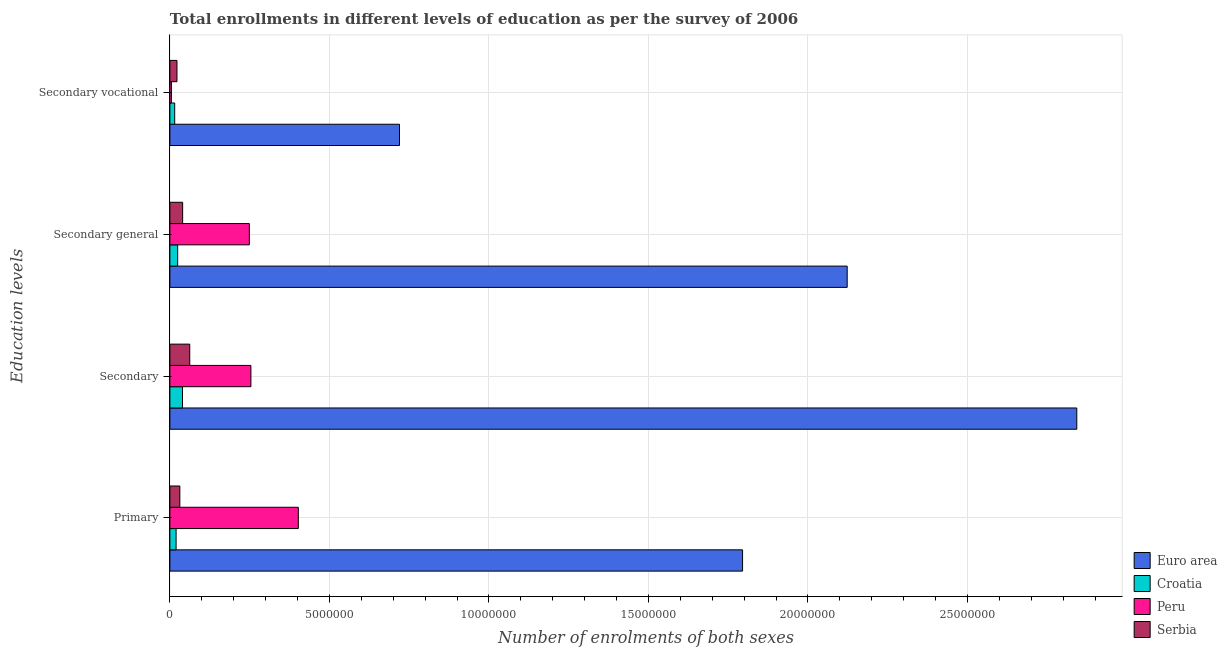How many different coloured bars are there?
Offer a very short reply. 4. How many groups of bars are there?
Provide a succinct answer. 4. Are the number of bars per tick equal to the number of legend labels?
Your response must be concise. Yes. Are the number of bars on each tick of the Y-axis equal?
Provide a short and direct response. Yes. How many bars are there on the 3rd tick from the top?
Your answer should be very brief. 4. What is the label of the 3rd group of bars from the top?
Your answer should be very brief. Secondary. What is the number of enrolments in secondary vocational education in Peru?
Ensure brevity in your answer.  4.86e+04. Across all countries, what is the maximum number of enrolments in primary education?
Offer a very short reply. 1.80e+07. Across all countries, what is the minimum number of enrolments in secondary education?
Ensure brevity in your answer.  3.96e+05. In which country was the number of enrolments in secondary general education minimum?
Offer a very short reply. Croatia. What is the total number of enrolments in secondary general education in the graph?
Provide a short and direct response. 2.44e+07. What is the difference between the number of enrolments in secondary general education in Peru and that in Croatia?
Your response must be concise. 2.25e+06. What is the difference between the number of enrolments in primary education in Serbia and the number of enrolments in secondary general education in Euro area?
Your answer should be compact. -2.09e+07. What is the average number of enrolments in primary education per country?
Ensure brevity in your answer.  5.62e+06. What is the difference between the number of enrolments in primary education and number of enrolments in secondary vocational education in Peru?
Your answer should be very brief. 3.98e+06. In how many countries, is the number of enrolments in primary education greater than 19000000 ?
Your response must be concise. 0. What is the ratio of the number of enrolments in primary education in Serbia to that in Euro area?
Your answer should be compact. 0.02. Is the number of enrolments in secondary vocational education in Serbia less than that in Peru?
Keep it short and to the point. No. What is the difference between the highest and the second highest number of enrolments in secondary general education?
Your answer should be compact. 1.87e+07. What is the difference between the highest and the lowest number of enrolments in primary education?
Keep it short and to the point. 1.78e+07. Is the sum of the number of enrolments in primary education in Peru and Croatia greater than the maximum number of enrolments in secondary education across all countries?
Give a very brief answer. No. What does the 2nd bar from the top in Secondary general represents?
Keep it short and to the point. Peru. Is it the case that in every country, the sum of the number of enrolments in primary education and number of enrolments in secondary education is greater than the number of enrolments in secondary general education?
Offer a very short reply. Yes. How many bars are there?
Give a very brief answer. 16. Are all the bars in the graph horizontal?
Keep it short and to the point. Yes. How many countries are there in the graph?
Make the answer very short. 4. Are the values on the major ticks of X-axis written in scientific E-notation?
Provide a succinct answer. No. Does the graph contain any zero values?
Ensure brevity in your answer.  No. How many legend labels are there?
Ensure brevity in your answer.  4. What is the title of the graph?
Make the answer very short. Total enrollments in different levels of education as per the survey of 2006. Does "Namibia" appear as one of the legend labels in the graph?
Ensure brevity in your answer.  No. What is the label or title of the X-axis?
Keep it short and to the point. Number of enrolments of both sexes. What is the label or title of the Y-axis?
Offer a terse response. Education levels. What is the Number of enrolments of both sexes in Euro area in Primary?
Offer a very short reply. 1.80e+07. What is the Number of enrolments of both sexes in Croatia in Primary?
Keep it short and to the point. 1.95e+05. What is the Number of enrolments of both sexes of Peru in Primary?
Keep it short and to the point. 4.03e+06. What is the Number of enrolments of both sexes of Serbia in Primary?
Keep it short and to the point. 3.13e+05. What is the Number of enrolments of both sexes of Euro area in Secondary?
Make the answer very short. 2.84e+07. What is the Number of enrolments of both sexes of Croatia in Secondary?
Keep it short and to the point. 3.96e+05. What is the Number of enrolments of both sexes in Peru in Secondary?
Provide a succinct answer. 2.54e+06. What is the Number of enrolments of both sexes in Serbia in Secondary?
Make the answer very short. 6.23e+05. What is the Number of enrolments of both sexes of Euro area in Secondary general?
Your answer should be compact. 2.12e+07. What is the Number of enrolments of both sexes in Croatia in Secondary general?
Offer a very short reply. 2.44e+05. What is the Number of enrolments of both sexes of Peru in Secondary general?
Offer a very short reply. 2.49e+06. What is the Number of enrolments of both sexes of Serbia in Secondary general?
Offer a very short reply. 4.00e+05. What is the Number of enrolments of both sexes of Euro area in Secondary vocational?
Your response must be concise. 7.20e+06. What is the Number of enrolments of both sexes in Croatia in Secondary vocational?
Give a very brief answer. 1.51e+05. What is the Number of enrolments of both sexes of Peru in Secondary vocational?
Make the answer very short. 4.86e+04. What is the Number of enrolments of both sexes of Serbia in Secondary vocational?
Offer a terse response. 2.23e+05. Across all Education levels, what is the maximum Number of enrolments of both sexes in Euro area?
Ensure brevity in your answer.  2.84e+07. Across all Education levels, what is the maximum Number of enrolments of both sexes of Croatia?
Provide a succinct answer. 3.96e+05. Across all Education levels, what is the maximum Number of enrolments of both sexes in Peru?
Ensure brevity in your answer.  4.03e+06. Across all Education levels, what is the maximum Number of enrolments of both sexes in Serbia?
Give a very brief answer. 6.23e+05. Across all Education levels, what is the minimum Number of enrolments of both sexes of Euro area?
Make the answer very short. 7.20e+06. Across all Education levels, what is the minimum Number of enrolments of both sexes of Croatia?
Your answer should be compact. 1.51e+05. Across all Education levels, what is the minimum Number of enrolments of both sexes of Peru?
Your response must be concise. 4.86e+04. Across all Education levels, what is the minimum Number of enrolments of both sexes of Serbia?
Provide a succinct answer. 2.23e+05. What is the total Number of enrolments of both sexes in Euro area in the graph?
Your response must be concise. 7.48e+07. What is the total Number of enrolments of both sexes in Croatia in the graph?
Keep it short and to the point. 9.86e+05. What is the total Number of enrolments of both sexes in Peru in the graph?
Keep it short and to the point. 9.11e+06. What is the total Number of enrolments of both sexes of Serbia in the graph?
Keep it short and to the point. 1.56e+06. What is the difference between the Number of enrolments of both sexes of Euro area in Primary and that in Secondary?
Offer a terse response. -1.05e+07. What is the difference between the Number of enrolments of both sexes of Croatia in Primary and that in Secondary?
Make the answer very short. -2.01e+05. What is the difference between the Number of enrolments of both sexes in Peru in Primary and that in Secondary?
Give a very brief answer. 1.49e+06. What is the difference between the Number of enrolments of both sexes of Serbia in Primary and that in Secondary?
Make the answer very short. -3.10e+05. What is the difference between the Number of enrolments of both sexes of Euro area in Primary and that in Secondary general?
Make the answer very short. -3.28e+06. What is the difference between the Number of enrolments of both sexes of Croatia in Primary and that in Secondary general?
Your answer should be compact. -4.96e+04. What is the difference between the Number of enrolments of both sexes in Peru in Primary and that in Secondary general?
Offer a terse response. 1.54e+06. What is the difference between the Number of enrolments of both sexes in Serbia in Primary and that in Secondary general?
Provide a succinct answer. -8.75e+04. What is the difference between the Number of enrolments of both sexes of Euro area in Primary and that in Secondary vocational?
Your answer should be compact. 1.08e+07. What is the difference between the Number of enrolments of both sexes of Croatia in Primary and that in Secondary vocational?
Your response must be concise. 4.33e+04. What is the difference between the Number of enrolments of both sexes of Peru in Primary and that in Secondary vocational?
Your answer should be compact. 3.98e+06. What is the difference between the Number of enrolments of both sexes in Serbia in Primary and that in Secondary vocational?
Offer a very short reply. 8.97e+04. What is the difference between the Number of enrolments of both sexes in Euro area in Secondary and that in Secondary general?
Your response must be concise. 7.20e+06. What is the difference between the Number of enrolments of both sexes of Croatia in Secondary and that in Secondary general?
Your response must be concise. 1.51e+05. What is the difference between the Number of enrolments of both sexes of Peru in Secondary and that in Secondary general?
Make the answer very short. 4.86e+04. What is the difference between the Number of enrolments of both sexes of Serbia in Secondary and that in Secondary general?
Offer a terse response. 2.23e+05. What is the difference between the Number of enrolments of both sexes in Euro area in Secondary and that in Secondary vocational?
Your answer should be compact. 2.12e+07. What is the difference between the Number of enrolments of both sexes in Croatia in Secondary and that in Secondary vocational?
Offer a terse response. 2.44e+05. What is the difference between the Number of enrolments of both sexes in Peru in Secondary and that in Secondary vocational?
Your response must be concise. 2.49e+06. What is the difference between the Number of enrolments of both sexes of Serbia in Secondary and that in Secondary vocational?
Ensure brevity in your answer.  4.00e+05. What is the difference between the Number of enrolments of both sexes in Euro area in Secondary general and that in Secondary vocational?
Give a very brief answer. 1.40e+07. What is the difference between the Number of enrolments of both sexes of Croatia in Secondary general and that in Secondary vocational?
Offer a terse response. 9.29e+04. What is the difference between the Number of enrolments of both sexes in Peru in Secondary general and that in Secondary vocational?
Give a very brief answer. 2.44e+06. What is the difference between the Number of enrolments of both sexes in Serbia in Secondary general and that in Secondary vocational?
Ensure brevity in your answer.  1.77e+05. What is the difference between the Number of enrolments of both sexes of Euro area in Primary and the Number of enrolments of both sexes of Croatia in Secondary?
Ensure brevity in your answer.  1.76e+07. What is the difference between the Number of enrolments of both sexes of Euro area in Primary and the Number of enrolments of both sexes of Peru in Secondary?
Your answer should be very brief. 1.54e+07. What is the difference between the Number of enrolments of both sexes in Euro area in Primary and the Number of enrolments of both sexes in Serbia in Secondary?
Provide a succinct answer. 1.73e+07. What is the difference between the Number of enrolments of both sexes in Croatia in Primary and the Number of enrolments of both sexes in Peru in Secondary?
Keep it short and to the point. -2.35e+06. What is the difference between the Number of enrolments of both sexes in Croatia in Primary and the Number of enrolments of both sexes in Serbia in Secondary?
Keep it short and to the point. -4.28e+05. What is the difference between the Number of enrolments of both sexes in Peru in Primary and the Number of enrolments of both sexes in Serbia in Secondary?
Make the answer very short. 3.40e+06. What is the difference between the Number of enrolments of both sexes in Euro area in Primary and the Number of enrolments of both sexes in Croatia in Secondary general?
Your answer should be compact. 1.77e+07. What is the difference between the Number of enrolments of both sexes in Euro area in Primary and the Number of enrolments of both sexes in Peru in Secondary general?
Offer a terse response. 1.55e+07. What is the difference between the Number of enrolments of both sexes in Euro area in Primary and the Number of enrolments of both sexes in Serbia in Secondary general?
Keep it short and to the point. 1.76e+07. What is the difference between the Number of enrolments of both sexes in Croatia in Primary and the Number of enrolments of both sexes in Peru in Secondary general?
Your answer should be compact. -2.30e+06. What is the difference between the Number of enrolments of both sexes of Croatia in Primary and the Number of enrolments of both sexes of Serbia in Secondary general?
Offer a very short reply. -2.05e+05. What is the difference between the Number of enrolments of both sexes in Peru in Primary and the Number of enrolments of both sexes in Serbia in Secondary general?
Ensure brevity in your answer.  3.63e+06. What is the difference between the Number of enrolments of both sexes in Euro area in Primary and the Number of enrolments of both sexes in Croatia in Secondary vocational?
Ensure brevity in your answer.  1.78e+07. What is the difference between the Number of enrolments of both sexes of Euro area in Primary and the Number of enrolments of both sexes of Peru in Secondary vocational?
Your answer should be compact. 1.79e+07. What is the difference between the Number of enrolments of both sexes in Euro area in Primary and the Number of enrolments of both sexes in Serbia in Secondary vocational?
Make the answer very short. 1.77e+07. What is the difference between the Number of enrolments of both sexes of Croatia in Primary and the Number of enrolments of both sexes of Peru in Secondary vocational?
Provide a short and direct response. 1.46e+05. What is the difference between the Number of enrolments of both sexes in Croatia in Primary and the Number of enrolments of both sexes in Serbia in Secondary vocational?
Offer a terse response. -2.80e+04. What is the difference between the Number of enrolments of both sexes in Peru in Primary and the Number of enrolments of both sexes in Serbia in Secondary vocational?
Provide a short and direct response. 3.80e+06. What is the difference between the Number of enrolments of both sexes of Euro area in Secondary and the Number of enrolments of both sexes of Croatia in Secondary general?
Offer a terse response. 2.82e+07. What is the difference between the Number of enrolments of both sexes of Euro area in Secondary and the Number of enrolments of both sexes of Peru in Secondary general?
Offer a terse response. 2.59e+07. What is the difference between the Number of enrolments of both sexes of Euro area in Secondary and the Number of enrolments of both sexes of Serbia in Secondary general?
Offer a very short reply. 2.80e+07. What is the difference between the Number of enrolments of both sexes of Croatia in Secondary and the Number of enrolments of both sexes of Peru in Secondary general?
Offer a terse response. -2.10e+06. What is the difference between the Number of enrolments of both sexes of Croatia in Secondary and the Number of enrolments of both sexes of Serbia in Secondary general?
Your answer should be very brief. -4208. What is the difference between the Number of enrolments of both sexes in Peru in Secondary and the Number of enrolments of both sexes in Serbia in Secondary general?
Offer a terse response. 2.14e+06. What is the difference between the Number of enrolments of both sexes of Euro area in Secondary and the Number of enrolments of both sexes of Croatia in Secondary vocational?
Provide a short and direct response. 2.83e+07. What is the difference between the Number of enrolments of both sexes of Euro area in Secondary and the Number of enrolments of both sexes of Peru in Secondary vocational?
Offer a very short reply. 2.84e+07. What is the difference between the Number of enrolments of both sexes in Euro area in Secondary and the Number of enrolments of both sexes in Serbia in Secondary vocational?
Your response must be concise. 2.82e+07. What is the difference between the Number of enrolments of both sexes of Croatia in Secondary and the Number of enrolments of both sexes of Peru in Secondary vocational?
Give a very brief answer. 3.47e+05. What is the difference between the Number of enrolments of both sexes of Croatia in Secondary and the Number of enrolments of both sexes of Serbia in Secondary vocational?
Make the answer very short. 1.73e+05. What is the difference between the Number of enrolments of both sexes of Peru in Secondary and the Number of enrolments of both sexes of Serbia in Secondary vocational?
Your response must be concise. 2.32e+06. What is the difference between the Number of enrolments of both sexes in Euro area in Secondary general and the Number of enrolments of both sexes in Croatia in Secondary vocational?
Offer a terse response. 2.11e+07. What is the difference between the Number of enrolments of both sexes in Euro area in Secondary general and the Number of enrolments of both sexes in Peru in Secondary vocational?
Your response must be concise. 2.12e+07. What is the difference between the Number of enrolments of both sexes of Euro area in Secondary general and the Number of enrolments of both sexes of Serbia in Secondary vocational?
Give a very brief answer. 2.10e+07. What is the difference between the Number of enrolments of both sexes in Croatia in Secondary general and the Number of enrolments of both sexes in Peru in Secondary vocational?
Your response must be concise. 1.96e+05. What is the difference between the Number of enrolments of both sexes of Croatia in Secondary general and the Number of enrolments of both sexes of Serbia in Secondary vocational?
Your response must be concise. 2.16e+04. What is the difference between the Number of enrolments of both sexes of Peru in Secondary general and the Number of enrolments of both sexes of Serbia in Secondary vocational?
Your answer should be very brief. 2.27e+06. What is the average Number of enrolments of both sexes in Euro area per Education levels?
Provide a succinct answer. 1.87e+07. What is the average Number of enrolments of both sexes of Croatia per Education levels?
Give a very brief answer. 2.47e+05. What is the average Number of enrolments of both sexes in Peru per Education levels?
Offer a terse response. 2.28e+06. What is the average Number of enrolments of both sexes of Serbia per Education levels?
Provide a short and direct response. 3.90e+05. What is the difference between the Number of enrolments of both sexes in Euro area and Number of enrolments of both sexes in Croatia in Primary?
Make the answer very short. 1.78e+07. What is the difference between the Number of enrolments of both sexes of Euro area and Number of enrolments of both sexes of Peru in Primary?
Give a very brief answer. 1.39e+07. What is the difference between the Number of enrolments of both sexes of Euro area and Number of enrolments of both sexes of Serbia in Primary?
Give a very brief answer. 1.76e+07. What is the difference between the Number of enrolments of both sexes in Croatia and Number of enrolments of both sexes in Peru in Primary?
Provide a short and direct response. -3.83e+06. What is the difference between the Number of enrolments of both sexes of Croatia and Number of enrolments of both sexes of Serbia in Primary?
Keep it short and to the point. -1.18e+05. What is the difference between the Number of enrolments of both sexes of Peru and Number of enrolments of both sexes of Serbia in Primary?
Provide a succinct answer. 3.71e+06. What is the difference between the Number of enrolments of both sexes in Euro area and Number of enrolments of both sexes in Croatia in Secondary?
Offer a very short reply. 2.80e+07. What is the difference between the Number of enrolments of both sexes in Euro area and Number of enrolments of both sexes in Peru in Secondary?
Keep it short and to the point. 2.59e+07. What is the difference between the Number of enrolments of both sexes of Euro area and Number of enrolments of both sexes of Serbia in Secondary?
Your answer should be compact. 2.78e+07. What is the difference between the Number of enrolments of both sexes of Croatia and Number of enrolments of both sexes of Peru in Secondary?
Your answer should be compact. -2.14e+06. What is the difference between the Number of enrolments of both sexes in Croatia and Number of enrolments of both sexes in Serbia in Secondary?
Ensure brevity in your answer.  -2.27e+05. What is the difference between the Number of enrolments of both sexes of Peru and Number of enrolments of both sexes of Serbia in Secondary?
Provide a succinct answer. 1.92e+06. What is the difference between the Number of enrolments of both sexes of Euro area and Number of enrolments of both sexes of Croatia in Secondary general?
Offer a very short reply. 2.10e+07. What is the difference between the Number of enrolments of both sexes of Euro area and Number of enrolments of both sexes of Peru in Secondary general?
Give a very brief answer. 1.87e+07. What is the difference between the Number of enrolments of both sexes of Euro area and Number of enrolments of both sexes of Serbia in Secondary general?
Provide a short and direct response. 2.08e+07. What is the difference between the Number of enrolments of both sexes of Croatia and Number of enrolments of both sexes of Peru in Secondary general?
Give a very brief answer. -2.25e+06. What is the difference between the Number of enrolments of both sexes of Croatia and Number of enrolments of both sexes of Serbia in Secondary general?
Offer a terse response. -1.56e+05. What is the difference between the Number of enrolments of both sexes of Peru and Number of enrolments of both sexes of Serbia in Secondary general?
Keep it short and to the point. 2.09e+06. What is the difference between the Number of enrolments of both sexes in Euro area and Number of enrolments of both sexes in Croatia in Secondary vocational?
Your answer should be very brief. 7.05e+06. What is the difference between the Number of enrolments of both sexes in Euro area and Number of enrolments of both sexes in Peru in Secondary vocational?
Offer a terse response. 7.15e+06. What is the difference between the Number of enrolments of both sexes in Euro area and Number of enrolments of both sexes in Serbia in Secondary vocational?
Ensure brevity in your answer.  6.97e+06. What is the difference between the Number of enrolments of both sexes of Croatia and Number of enrolments of both sexes of Peru in Secondary vocational?
Provide a succinct answer. 1.03e+05. What is the difference between the Number of enrolments of both sexes in Croatia and Number of enrolments of both sexes in Serbia in Secondary vocational?
Give a very brief answer. -7.13e+04. What is the difference between the Number of enrolments of both sexes of Peru and Number of enrolments of both sexes of Serbia in Secondary vocational?
Ensure brevity in your answer.  -1.74e+05. What is the ratio of the Number of enrolments of both sexes in Euro area in Primary to that in Secondary?
Ensure brevity in your answer.  0.63. What is the ratio of the Number of enrolments of both sexes of Croatia in Primary to that in Secondary?
Provide a succinct answer. 0.49. What is the ratio of the Number of enrolments of both sexes in Peru in Primary to that in Secondary?
Make the answer very short. 1.59. What is the ratio of the Number of enrolments of both sexes in Serbia in Primary to that in Secondary?
Your answer should be compact. 0.5. What is the ratio of the Number of enrolments of both sexes of Euro area in Primary to that in Secondary general?
Your response must be concise. 0.85. What is the ratio of the Number of enrolments of both sexes of Croatia in Primary to that in Secondary general?
Ensure brevity in your answer.  0.8. What is the ratio of the Number of enrolments of both sexes of Peru in Primary to that in Secondary general?
Provide a short and direct response. 1.62. What is the ratio of the Number of enrolments of both sexes of Serbia in Primary to that in Secondary general?
Give a very brief answer. 0.78. What is the ratio of the Number of enrolments of both sexes of Euro area in Primary to that in Secondary vocational?
Provide a short and direct response. 2.49. What is the ratio of the Number of enrolments of both sexes in Croatia in Primary to that in Secondary vocational?
Your answer should be compact. 1.29. What is the ratio of the Number of enrolments of both sexes of Peru in Primary to that in Secondary vocational?
Keep it short and to the point. 82.78. What is the ratio of the Number of enrolments of both sexes in Serbia in Primary to that in Secondary vocational?
Offer a terse response. 1.4. What is the ratio of the Number of enrolments of both sexes of Euro area in Secondary to that in Secondary general?
Give a very brief answer. 1.34. What is the ratio of the Number of enrolments of both sexes of Croatia in Secondary to that in Secondary general?
Ensure brevity in your answer.  1.62. What is the ratio of the Number of enrolments of both sexes of Peru in Secondary to that in Secondary general?
Provide a succinct answer. 1.02. What is the ratio of the Number of enrolments of both sexes of Serbia in Secondary to that in Secondary general?
Keep it short and to the point. 1.56. What is the ratio of the Number of enrolments of both sexes of Euro area in Secondary to that in Secondary vocational?
Make the answer very short. 3.95. What is the ratio of the Number of enrolments of both sexes in Croatia in Secondary to that in Secondary vocational?
Offer a very short reply. 2.61. What is the ratio of the Number of enrolments of both sexes of Peru in Secondary to that in Secondary vocational?
Offer a very short reply. 52.22. What is the ratio of the Number of enrolments of both sexes in Serbia in Secondary to that in Secondary vocational?
Keep it short and to the point. 2.8. What is the ratio of the Number of enrolments of both sexes of Euro area in Secondary general to that in Secondary vocational?
Your answer should be very brief. 2.95. What is the ratio of the Number of enrolments of both sexes in Croatia in Secondary general to that in Secondary vocational?
Your response must be concise. 1.61. What is the ratio of the Number of enrolments of both sexes in Peru in Secondary general to that in Secondary vocational?
Your answer should be very brief. 51.22. What is the ratio of the Number of enrolments of both sexes in Serbia in Secondary general to that in Secondary vocational?
Keep it short and to the point. 1.8. What is the difference between the highest and the second highest Number of enrolments of both sexes in Euro area?
Offer a very short reply. 7.20e+06. What is the difference between the highest and the second highest Number of enrolments of both sexes of Croatia?
Give a very brief answer. 1.51e+05. What is the difference between the highest and the second highest Number of enrolments of both sexes in Peru?
Give a very brief answer. 1.49e+06. What is the difference between the highest and the second highest Number of enrolments of both sexes of Serbia?
Ensure brevity in your answer.  2.23e+05. What is the difference between the highest and the lowest Number of enrolments of both sexes of Euro area?
Your answer should be compact. 2.12e+07. What is the difference between the highest and the lowest Number of enrolments of both sexes in Croatia?
Your answer should be very brief. 2.44e+05. What is the difference between the highest and the lowest Number of enrolments of both sexes in Peru?
Provide a short and direct response. 3.98e+06. What is the difference between the highest and the lowest Number of enrolments of both sexes in Serbia?
Ensure brevity in your answer.  4.00e+05. 